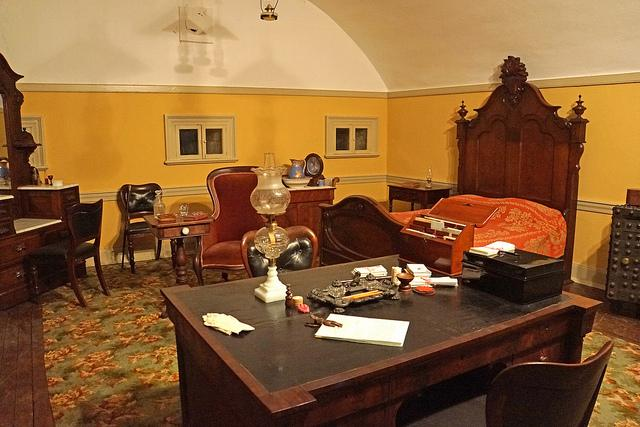What kind of fuel does the lamp use? Please explain your reasoning. fossil. The lamp is powered by oil. 